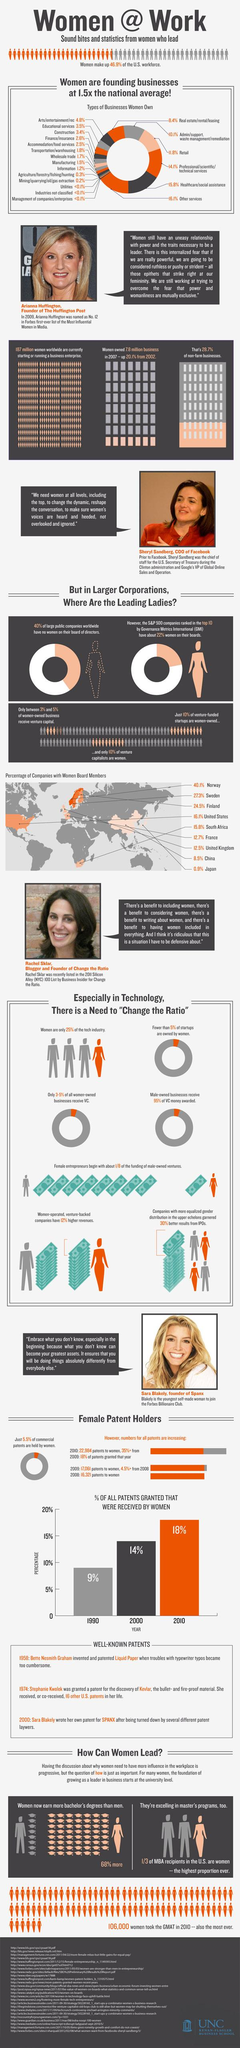Outline some significant characteristics in this image. In the years 2000 and 2010, women received a total of 32% of patents. In Finland and France taken together, the percentage of companies with women on their boards is 37.2%. In China and Japan, only 9.4% of companies have women serving on their boards, taken together. The combined percentage of companies with women board members in Norway and Sweden is 67.4%. According to the data, the percentage of companies with women board members in the US and UK, taken together, is 28.6%. 